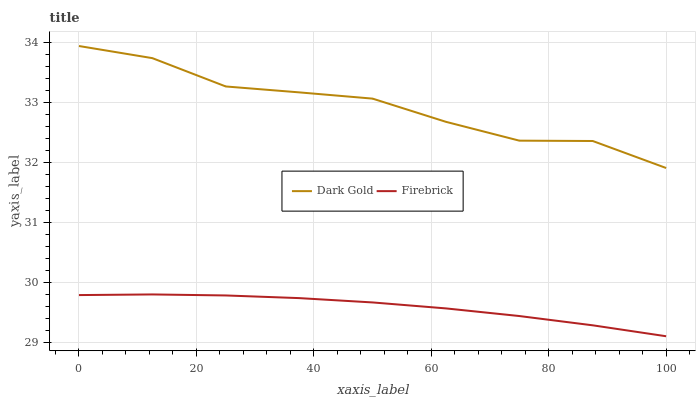Does Firebrick have the minimum area under the curve?
Answer yes or no. Yes. Does Dark Gold have the maximum area under the curve?
Answer yes or no. Yes. Does Dark Gold have the minimum area under the curve?
Answer yes or no. No. Is Firebrick the smoothest?
Answer yes or no. Yes. Is Dark Gold the roughest?
Answer yes or no. Yes. Is Dark Gold the smoothest?
Answer yes or no. No. Does Firebrick have the lowest value?
Answer yes or no. Yes. Does Dark Gold have the lowest value?
Answer yes or no. No. Does Dark Gold have the highest value?
Answer yes or no. Yes. Is Firebrick less than Dark Gold?
Answer yes or no. Yes. Is Dark Gold greater than Firebrick?
Answer yes or no. Yes. Does Firebrick intersect Dark Gold?
Answer yes or no. No. 